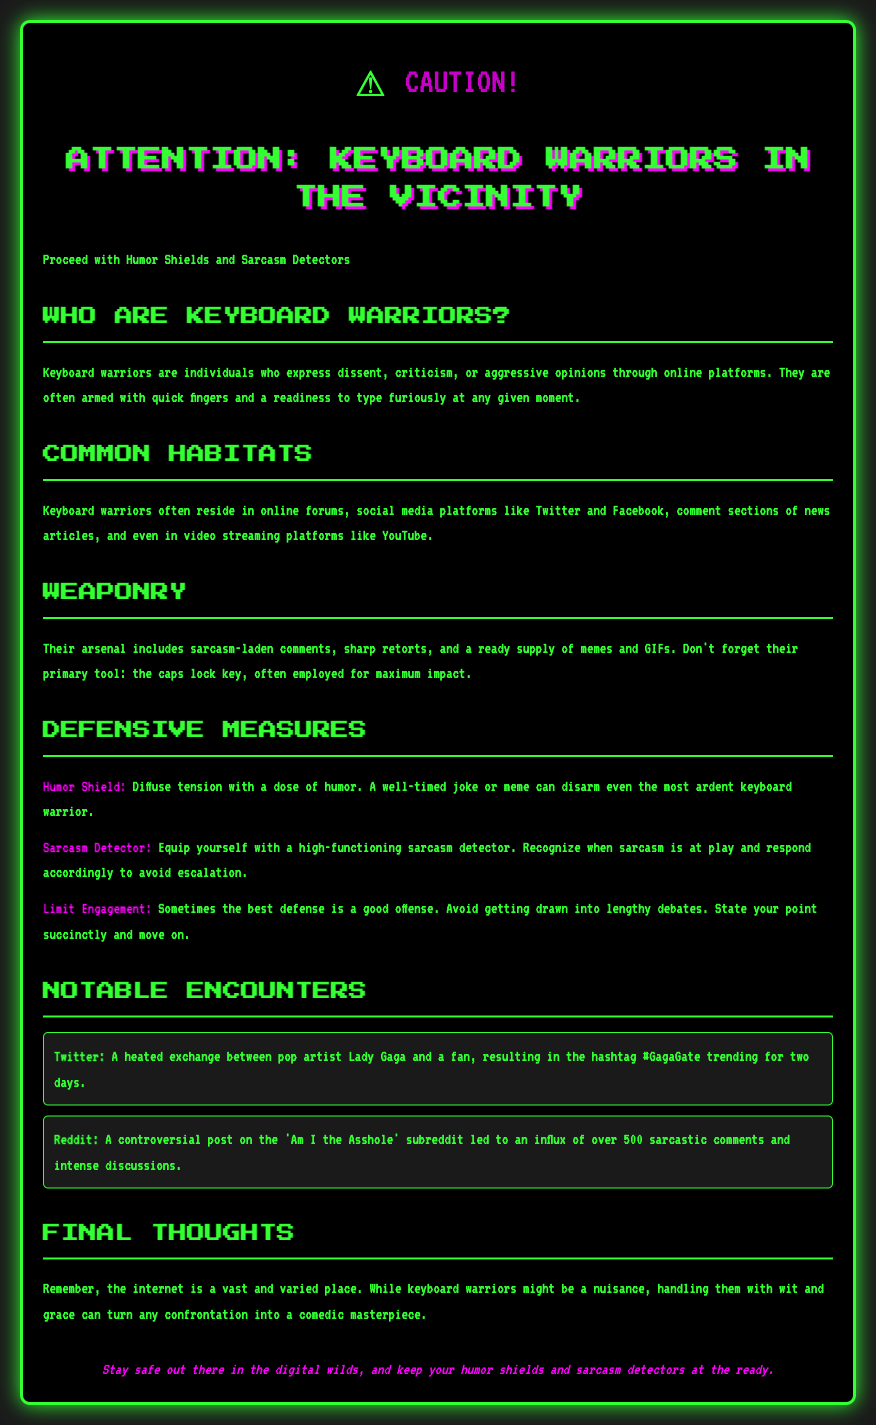What is the warning label title? The warning label title is prominently displayed at the top of the document as "Attention: Keyboard Warriors in the Vicinity."
Answer: Attention: Keyboard Warriors in the Vicinity What should you proceed with? The document advises proceeding with "Humor Shields and Sarcasm Detectors."
Answer: Humor Shields and Sarcasm Detectors What online platforms are mentioned as common habitats for keyboard warriors? The document lists "Twitter, Facebook, and YouTube" as common platforms where keyboard warriors can be found.
Answer: Twitter, Facebook, YouTube What is one component of the keyboard warriors' weaponry? The document states that one component of their weaponry is the "caps lock key."
Answer: caps lock key How many notable encounters are included in the document? The document mentions "two" notable encounters in the section titled "Notable Encounters."
Answer: two What is a tip provided for engaging with keyboard warriors? The document suggests using a "Humor Shield" as a tip for handling keyboard warriors.
Answer: Humor Shield What was the hashtag that trended on Twitter following a notable keyboard warrior incident? The document references the trending hashtag "#GagaGate" related to Lady Gaga's interaction with a fan.
Answer: #GagaGate What subreddit is mentioned in relation to a controversial post? The document indicates that the "Am I the Asshole" subreddit is associated with a notable encounter.
Answer: Am I the Asshole What is the color of the text in the document? The document states that the text color is "#33ff33," which is a bright green.
Answer: #33ff33 